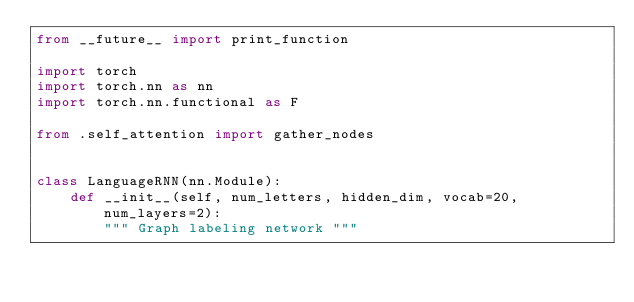<code> <loc_0><loc_0><loc_500><loc_500><_Python_>from __future__ import print_function

import torch
import torch.nn as nn
import torch.nn.functional as F

from .self_attention import gather_nodes


class LanguageRNN(nn.Module):
    def __init__(self, num_letters, hidden_dim, vocab=20, num_layers=2):
        """ Graph labeling network """</code> 